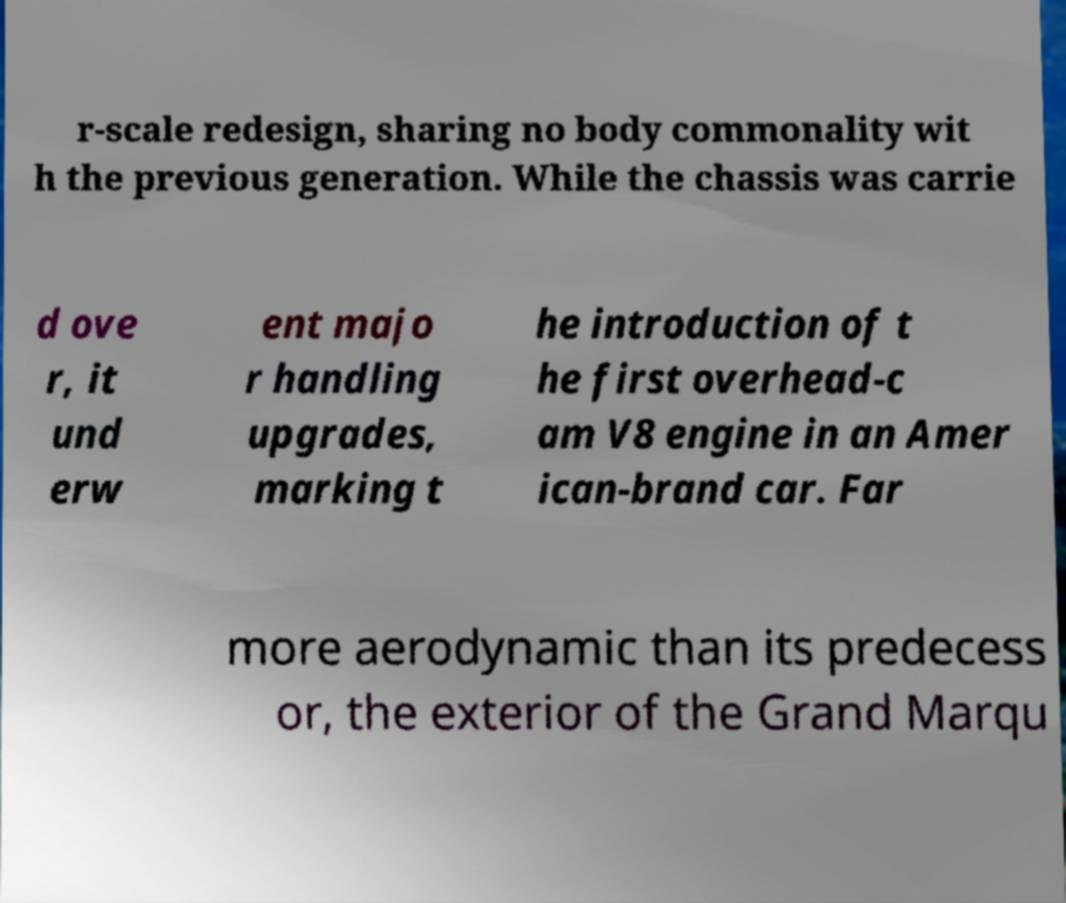Could you assist in decoding the text presented in this image and type it out clearly? r-scale redesign, sharing no body commonality wit h the previous generation. While the chassis was carrie d ove r, it und erw ent majo r handling upgrades, marking t he introduction of t he first overhead-c am V8 engine in an Amer ican-brand car. Far more aerodynamic than its predecess or, the exterior of the Grand Marqu 